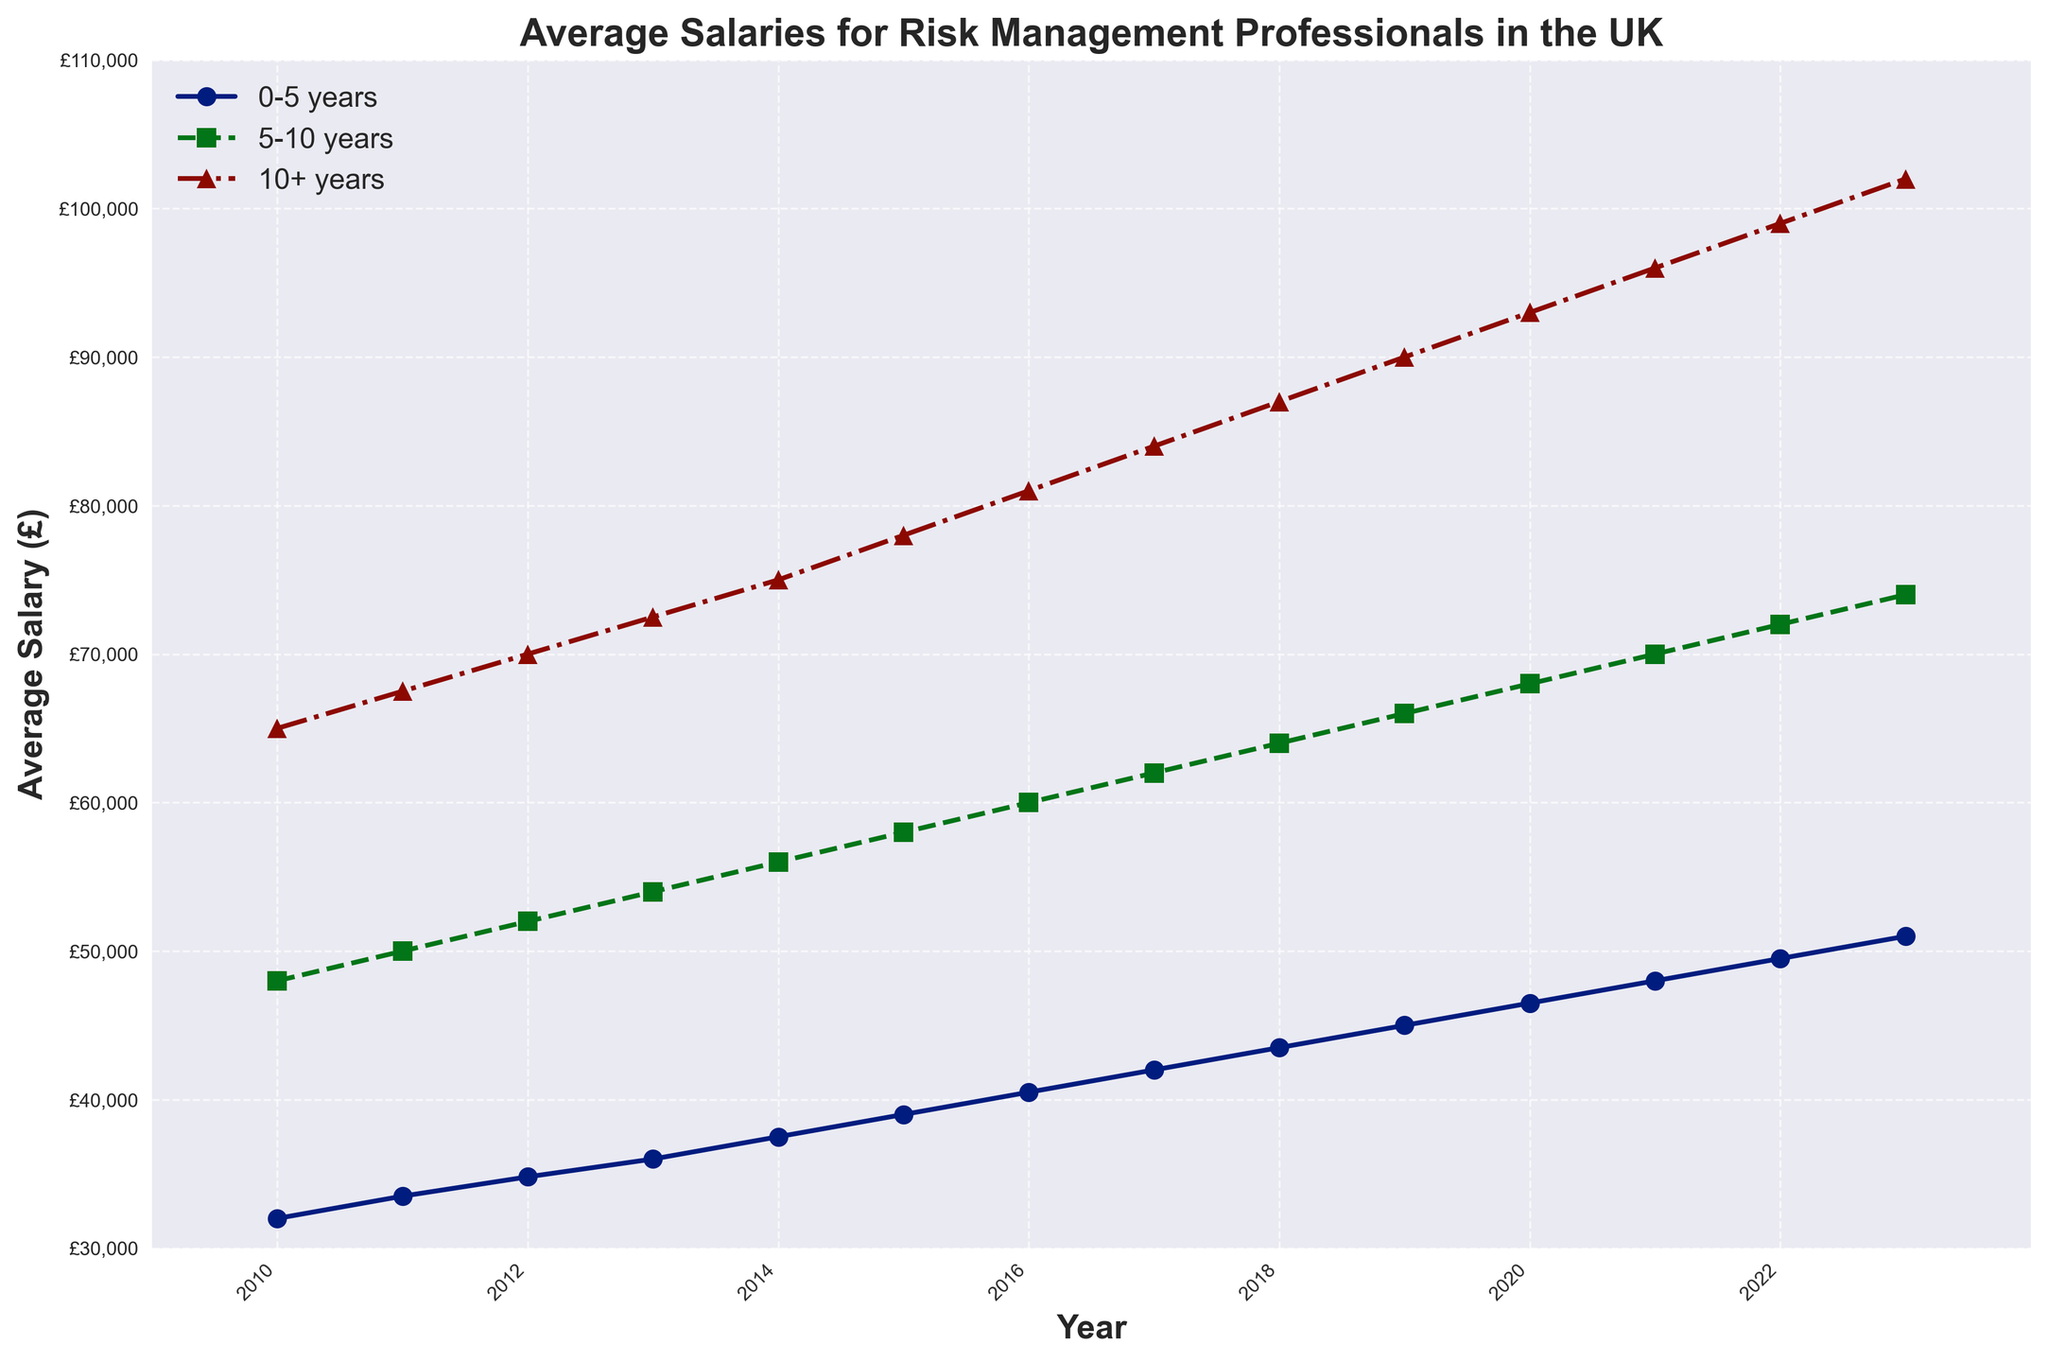What is the average salary for risk management professionals with 10+ years of experience in 2020? From the figure, find the line corresponding to "10+ years experience" and check the value at year 2020 on the x-axis.
Answer: £93,000 What is the difference in the average salary between professionals with 0-5 years of experience and those with 5-10 years of experience in 2015? Identify the points for 2015 on the "0-5 years experience" and "5-10 years experience" lines. Subtract the salary of the 0-5 years group from the 5-10 years group.
Answer: £19,000 Which experience level saw the most consistent growth in average salary from 2010 to 2023? Compare the shapes of the three lines. The "10+ years experience" line appears to be the most consistently increasing without major fluctuations.
Answer: 10+ years experience By how much did the average salary of risk management professionals with 10+ years of experience increase from 2010 to 2023? Find the values in 2010 and 2023 on the "10+ years experience" line and calculate the difference.
Answer: £37,000 In which year did professionals with 5-10 years of experience surpass an average salary of £70,000? Look at the "5-10 years experience" line and identify the year when the line first reaches or exceeds £70,000.
Answer: 2021 Is there any year where the average salary for professionals with 0-5 years of experience is equal to or greater than £50,000? Examine the "0-5 years experience" line to find any point that reaches or exceeds £50,000.
Answer: 2023 How does the rate of salary increase from 2020 to 2023 compare between the 0-5 years experience group and the 10+ years experience group? Calculate the salary increase for both groups from 2020 to 2023 and compare the values. (51000-46500) for 0-5 years, (102000-93000) for 10+ years.
Answer: 0-5 years: £4,500, 10+ years: £9,000 Which experience level shows the highest average salary each year? Look at the highest point among the three lines for each year to see which line is always on top.
Answer: 10+ years experience Between 2012 and 2015, which experience level saw the largest absolute increase in average salary? Assess the increase for each experience level by finding the difference in salary values from 2012 to 2015.
Answer: 10+ years experience During which years did the average salary for 5-10 years experience increase by exactly £2,000 from the previous year? Look at the "5-10 years experience" line and find years where the increase from one year to the next is £2,000.
Answer: 2017, 2019 